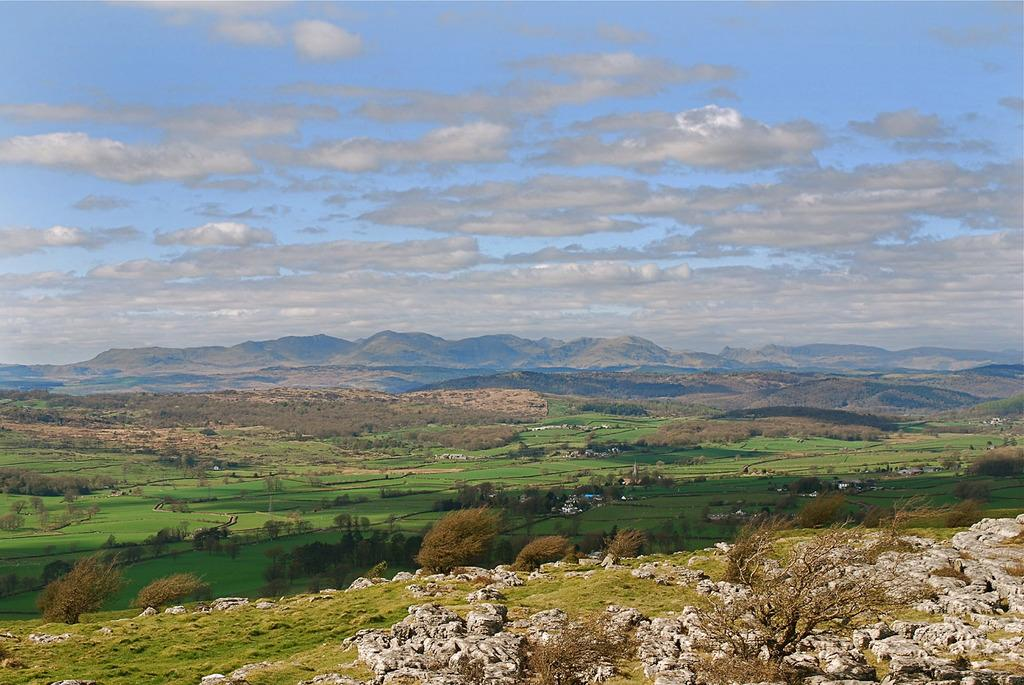What type of vegetation can be seen in the image? There is grass in the image. What other natural elements are present in the image? There are trees and hills in the image. What can be seen in the background of the image? The sky is visible in the background of the image. What type of circle can be seen in the image? There is no circle present in the image; it features grass, trees, hills, and the sky. Is there a bath visible in the image? There is no bath present in the image. 